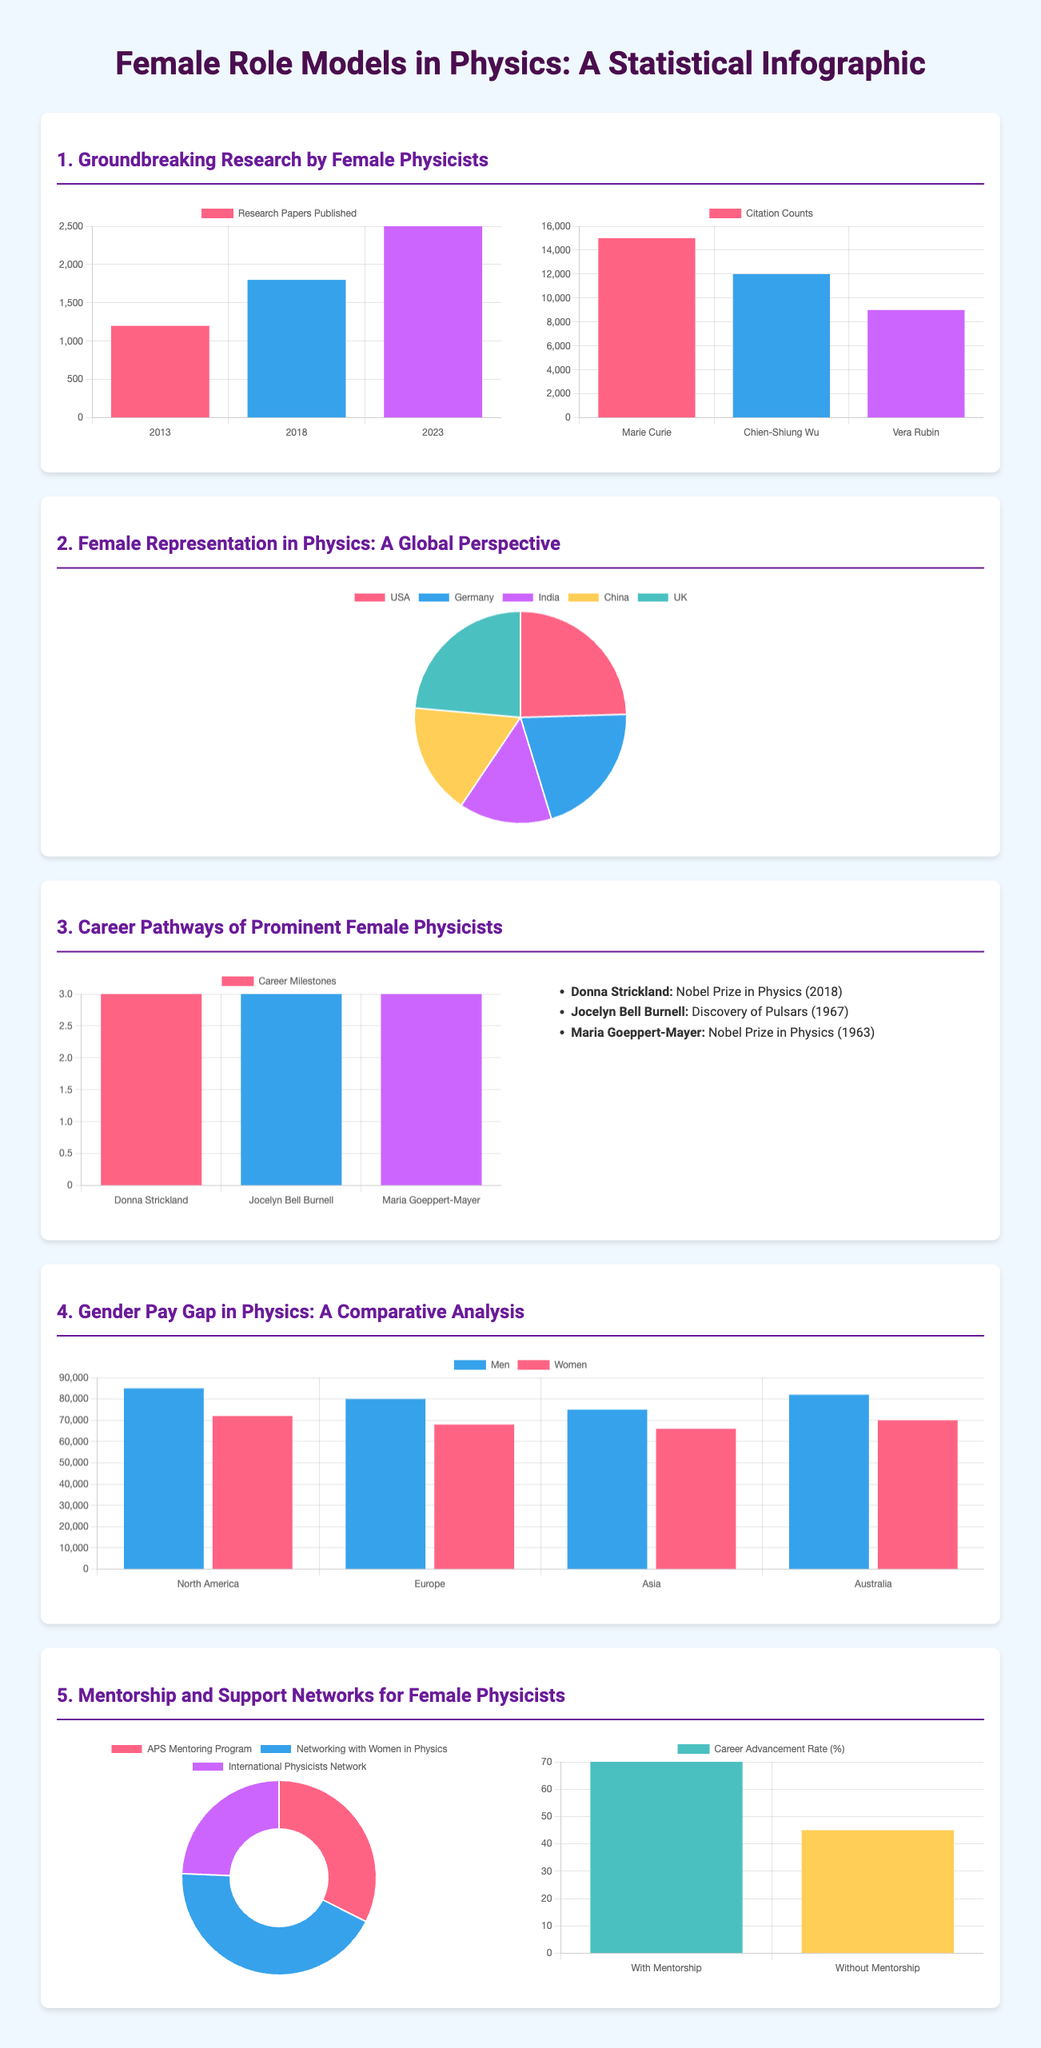What is the increase in research papers published by female physicists from 2013 to 2023? The increase is calculated by the difference in research papers published in 2023 and 2013, which is 2500 - 1200 = 1300.
Answer: 1300 Who received the Nobel Prize in Physics in 2018? The document lists Donna Strickland as the recipient of the Nobel Prize in Physics in 2018.
Answer: Donna Strickland What percentage of women in physics does China represent? The pie chart shows that China represents 18% of women in physics.
Answer: 18% How many citation counts does Marie Curie have? The citation chart specifies that Marie Curie has 15000 citations.
Answer: 15000 What is the average salary for women physicists in North America? The bar graph indicates that the average salary for women physicists in North America is 72000.
Answer: 72000 What are the names of two mentorship programs mentioned in the infographic? The document highlights APS Mentoring Program and Networking with Women in Physics as mentorship programs.
Answer: APS Mentoring Program, Networking with Women in Physics What is the impact of mentorship on career advancement for female physicists in percentage? The document states that the career advancement rate with mentorship is 70%, while without mentorship, it is 45%.
Answer: 70% How many career milestones did Jocelyn Bell Burnell achieve? The career pathways chart shows that Jocelyn Bell Burnell achieved 3 major career milestones.
Answer: 3 What is the total number of research papers published by female physicists in 2023? The data shows that there were 2500 research papers published by female physicists in 2023.
Answer: 2500 